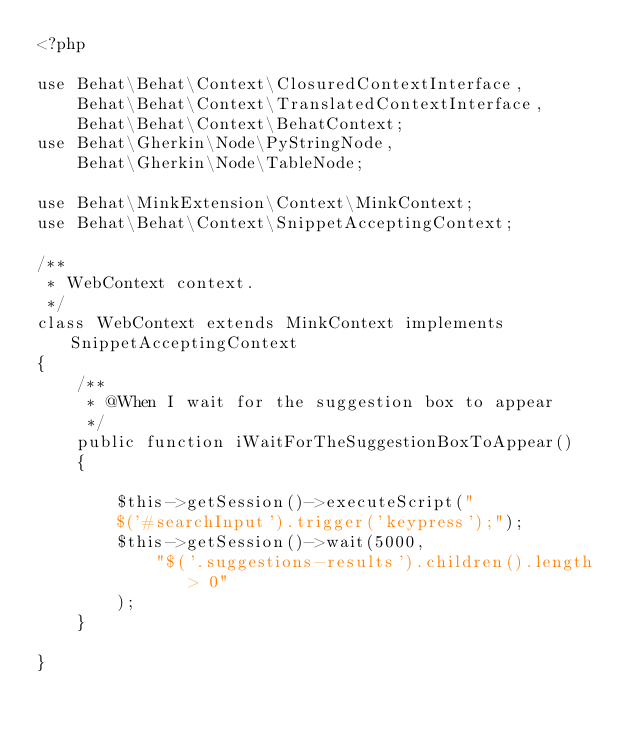<code> <loc_0><loc_0><loc_500><loc_500><_PHP_><?php

use Behat\Behat\Context\ClosuredContextInterface,
    Behat\Behat\Context\TranslatedContextInterface,
    Behat\Behat\Context\BehatContext;
use Behat\Gherkin\Node\PyStringNode,
    Behat\Gherkin\Node\TableNode;

use Behat\MinkExtension\Context\MinkContext;
use Behat\Behat\Context\SnippetAcceptingContext;

/**
 * WebContext context.
 */
class WebContext extends MinkContext implements SnippetAcceptingContext
{
    /**
     * @When I wait for the suggestion box to appear
     */
    public function iWaitForTheSuggestionBoxToAppear()
    {

        $this->getSession()->executeScript("
        $('#searchInput').trigger('keypress');");
        $this->getSession()->wait(5000,
            "$('.suggestions-results').children().length > 0"
        );
    }

}
</code> 